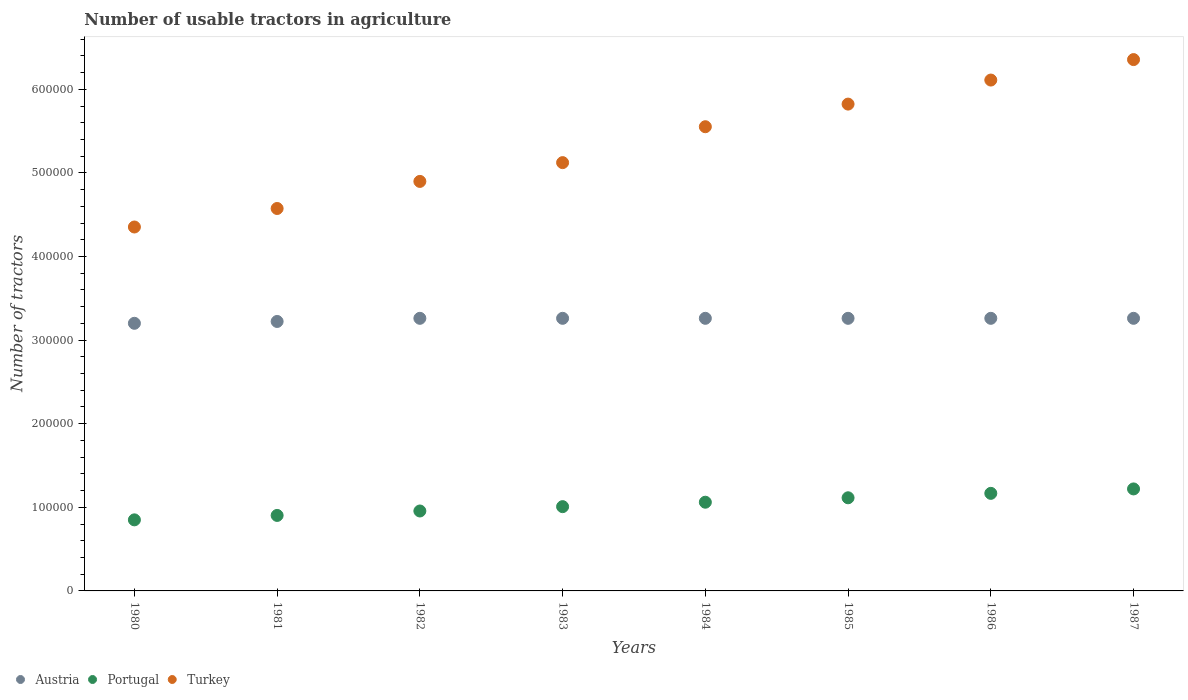What is the number of usable tractors in agriculture in Austria in 1981?
Your response must be concise. 3.22e+05. Across all years, what is the maximum number of usable tractors in agriculture in Portugal?
Provide a short and direct response. 1.22e+05. Across all years, what is the minimum number of usable tractors in agriculture in Portugal?
Provide a short and direct response. 8.50e+04. In which year was the number of usable tractors in agriculture in Austria maximum?
Offer a terse response. 1982. What is the total number of usable tractors in agriculture in Portugal in the graph?
Your answer should be compact. 8.28e+05. What is the difference between the number of usable tractors in agriculture in Turkey in 1982 and that in 1987?
Your answer should be very brief. -1.46e+05. What is the difference between the number of usable tractors in agriculture in Austria in 1984 and the number of usable tractors in agriculture in Portugal in 1987?
Keep it short and to the point. 2.04e+05. What is the average number of usable tractors in agriculture in Austria per year?
Make the answer very short. 3.25e+05. In the year 1987, what is the difference between the number of usable tractors in agriculture in Turkey and number of usable tractors in agriculture in Austria?
Offer a terse response. 3.09e+05. In how many years, is the number of usable tractors in agriculture in Portugal greater than 40000?
Provide a succinct answer. 8. What is the ratio of the number of usable tractors in agriculture in Portugal in 1980 to that in 1982?
Provide a succinct answer. 0.89. Is the number of usable tractors in agriculture in Austria in 1985 less than that in 1987?
Your answer should be very brief. No. What is the difference between the highest and the second highest number of usable tractors in agriculture in Portugal?
Give a very brief answer. 5300. What is the difference between the highest and the lowest number of usable tractors in agriculture in Portugal?
Offer a very short reply. 3.70e+04. In how many years, is the number of usable tractors in agriculture in Turkey greater than the average number of usable tractors in agriculture in Turkey taken over all years?
Offer a terse response. 4. Is the number of usable tractors in agriculture in Austria strictly less than the number of usable tractors in agriculture in Turkey over the years?
Offer a terse response. Yes. How many years are there in the graph?
Keep it short and to the point. 8. Are the values on the major ticks of Y-axis written in scientific E-notation?
Provide a succinct answer. No. Where does the legend appear in the graph?
Provide a short and direct response. Bottom left. How many legend labels are there?
Your response must be concise. 3. What is the title of the graph?
Provide a succinct answer. Number of usable tractors in agriculture. What is the label or title of the Y-axis?
Ensure brevity in your answer.  Number of tractors. What is the Number of tractors in Austria in 1980?
Offer a terse response. 3.20e+05. What is the Number of tractors of Portugal in 1980?
Provide a succinct answer. 8.50e+04. What is the Number of tractors of Turkey in 1980?
Offer a terse response. 4.35e+05. What is the Number of tractors of Austria in 1981?
Provide a succinct answer. 3.22e+05. What is the Number of tractors of Portugal in 1981?
Your answer should be compact. 9.03e+04. What is the Number of tractors of Turkey in 1981?
Offer a terse response. 4.57e+05. What is the Number of tractors in Austria in 1982?
Offer a terse response. 3.26e+05. What is the Number of tractors in Portugal in 1982?
Provide a succinct answer. 9.56e+04. What is the Number of tractors in Turkey in 1982?
Your answer should be compact. 4.90e+05. What is the Number of tractors of Austria in 1983?
Ensure brevity in your answer.  3.26e+05. What is the Number of tractors in Portugal in 1983?
Offer a very short reply. 1.01e+05. What is the Number of tractors of Turkey in 1983?
Provide a short and direct response. 5.12e+05. What is the Number of tractors of Austria in 1984?
Provide a succinct answer. 3.26e+05. What is the Number of tractors of Portugal in 1984?
Offer a very short reply. 1.06e+05. What is the Number of tractors in Turkey in 1984?
Offer a very short reply. 5.55e+05. What is the Number of tractors of Austria in 1985?
Ensure brevity in your answer.  3.26e+05. What is the Number of tractors in Portugal in 1985?
Keep it short and to the point. 1.11e+05. What is the Number of tractors in Turkey in 1985?
Make the answer very short. 5.82e+05. What is the Number of tractors in Austria in 1986?
Provide a succinct answer. 3.26e+05. What is the Number of tractors of Portugal in 1986?
Keep it short and to the point. 1.17e+05. What is the Number of tractors of Turkey in 1986?
Offer a very short reply. 6.11e+05. What is the Number of tractors of Austria in 1987?
Your answer should be very brief. 3.26e+05. What is the Number of tractors in Portugal in 1987?
Offer a terse response. 1.22e+05. What is the Number of tractors in Turkey in 1987?
Make the answer very short. 6.36e+05. Across all years, what is the maximum Number of tractors of Austria?
Your response must be concise. 3.26e+05. Across all years, what is the maximum Number of tractors in Portugal?
Your answer should be very brief. 1.22e+05. Across all years, what is the maximum Number of tractors of Turkey?
Offer a very short reply. 6.36e+05. Across all years, what is the minimum Number of tractors in Austria?
Your answer should be compact. 3.20e+05. Across all years, what is the minimum Number of tractors of Portugal?
Offer a very short reply. 8.50e+04. Across all years, what is the minimum Number of tractors in Turkey?
Ensure brevity in your answer.  4.35e+05. What is the total Number of tractors in Austria in the graph?
Offer a very short reply. 2.60e+06. What is the total Number of tractors in Portugal in the graph?
Offer a terse response. 8.28e+05. What is the total Number of tractors in Turkey in the graph?
Your response must be concise. 4.28e+06. What is the difference between the Number of tractors of Austria in 1980 and that in 1981?
Ensure brevity in your answer.  -2200. What is the difference between the Number of tractors of Portugal in 1980 and that in 1981?
Your response must be concise. -5300. What is the difference between the Number of tractors in Turkey in 1980 and that in 1981?
Your response must be concise. -2.21e+04. What is the difference between the Number of tractors of Austria in 1980 and that in 1982?
Keep it short and to the point. -5960. What is the difference between the Number of tractors of Portugal in 1980 and that in 1982?
Provide a succinct answer. -1.06e+04. What is the difference between the Number of tractors of Turkey in 1980 and that in 1982?
Make the answer very short. -5.45e+04. What is the difference between the Number of tractors of Austria in 1980 and that in 1983?
Keep it short and to the point. -5960. What is the difference between the Number of tractors in Portugal in 1980 and that in 1983?
Your answer should be compact. -1.58e+04. What is the difference between the Number of tractors of Turkey in 1980 and that in 1983?
Ensure brevity in your answer.  -7.70e+04. What is the difference between the Number of tractors of Austria in 1980 and that in 1984?
Your answer should be very brief. -5960. What is the difference between the Number of tractors of Portugal in 1980 and that in 1984?
Your answer should be very brief. -2.11e+04. What is the difference between the Number of tractors in Turkey in 1980 and that in 1984?
Your answer should be very brief. -1.20e+05. What is the difference between the Number of tractors of Austria in 1980 and that in 1985?
Offer a terse response. -5960. What is the difference between the Number of tractors of Portugal in 1980 and that in 1985?
Ensure brevity in your answer.  -2.64e+04. What is the difference between the Number of tractors of Turkey in 1980 and that in 1985?
Ensure brevity in your answer.  -1.47e+05. What is the difference between the Number of tractors in Austria in 1980 and that in 1986?
Offer a very short reply. -5960. What is the difference between the Number of tractors of Portugal in 1980 and that in 1986?
Offer a very short reply. -3.17e+04. What is the difference between the Number of tractors in Turkey in 1980 and that in 1986?
Make the answer very short. -1.76e+05. What is the difference between the Number of tractors of Austria in 1980 and that in 1987?
Make the answer very short. -5960. What is the difference between the Number of tractors of Portugal in 1980 and that in 1987?
Provide a succinct answer. -3.70e+04. What is the difference between the Number of tractors in Turkey in 1980 and that in 1987?
Your answer should be very brief. -2.00e+05. What is the difference between the Number of tractors of Austria in 1981 and that in 1982?
Your response must be concise. -3760. What is the difference between the Number of tractors in Portugal in 1981 and that in 1982?
Your answer should be compact. -5300. What is the difference between the Number of tractors in Turkey in 1981 and that in 1982?
Keep it short and to the point. -3.24e+04. What is the difference between the Number of tractors of Austria in 1981 and that in 1983?
Your answer should be compact. -3760. What is the difference between the Number of tractors in Portugal in 1981 and that in 1983?
Provide a succinct answer. -1.05e+04. What is the difference between the Number of tractors of Turkey in 1981 and that in 1983?
Your answer should be very brief. -5.49e+04. What is the difference between the Number of tractors in Austria in 1981 and that in 1984?
Provide a succinct answer. -3760. What is the difference between the Number of tractors of Portugal in 1981 and that in 1984?
Keep it short and to the point. -1.58e+04. What is the difference between the Number of tractors of Turkey in 1981 and that in 1984?
Ensure brevity in your answer.  -9.78e+04. What is the difference between the Number of tractors of Austria in 1981 and that in 1985?
Your answer should be very brief. -3760. What is the difference between the Number of tractors of Portugal in 1981 and that in 1985?
Provide a short and direct response. -2.11e+04. What is the difference between the Number of tractors of Turkey in 1981 and that in 1985?
Offer a terse response. -1.25e+05. What is the difference between the Number of tractors in Austria in 1981 and that in 1986?
Ensure brevity in your answer.  -3760. What is the difference between the Number of tractors of Portugal in 1981 and that in 1986?
Provide a short and direct response. -2.64e+04. What is the difference between the Number of tractors of Turkey in 1981 and that in 1986?
Offer a very short reply. -1.54e+05. What is the difference between the Number of tractors in Austria in 1981 and that in 1987?
Offer a very short reply. -3760. What is the difference between the Number of tractors of Portugal in 1981 and that in 1987?
Your response must be concise. -3.17e+04. What is the difference between the Number of tractors of Turkey in 1981 and that in 1987?
Offer a very short reply. -1.78e+05. What is the difference between the Number of tractors in Portugal in 1982 and that in 1983?
Your answer should be compact. -5200. What is the difference between the Number of tractors of Turkey in 1982 and that in 1983?
Give a very brief answer. -2.25e+04. What is the difference between the Number of tractors in Portugal in 1982 and that in 1984?
Give a very brief answer. -1.05e+04. What is the difference between the Number of tractors in Turkey in 1982 and that in 1984?
Make the answer very short. -6.54e+04. What is the difference between the Number of tractors in Portugal in 1982 and that in 1985?
Your response must be concise. -1.58e+04. What is the difference between the Number of tractors in Turkey in 1982 and that in 1985?
Your response must be concise. -9.25e+04. What is the difference between the Number of tractors of Portugal in 1982 and that in 1986?
Provide a succinct answer. -2.11e+04. What is the difference between the Number of tractors of Turkey in 1982 and that in 1986?
Keep it short and to the point. -1.21e+05. What is the difference between the Number of tractors of Portugal in 1982 and that in 1987?
Keep it short and to the point. -2.64e+04. What is the difference between the Number of tractors of Turkey in 1982 and that in 1987?
Provide a succinct answer. -1.46e+05. What is the difference between the Number of tractors of Portugal in 1983 and that in 1984?
Give a very brief answer. -5300. What is the difference between the Number of tractors in Turkey in 1983 and that in 1984?
Keep it short and to the point. -4.29e+04. What is the difference between the Number of tractors of Austria in 1983 and that in 1985?
Provide a succinct answer. 0. What is the difference between the Number of tractors in Portugal in 1983 and that in 1985?
Make the answer very short. -1.06e+04. What is the difference between the Number of tractors of Turkey in 1983 and that in 1985?
Your answer should be compact. -7.00e+04. What is the difference between the Number of tractors in Austria in 1983 and that in 1986?
Give a very brief answer. 0. What is the difference between the Number of tractors in Portugal in 1983 and that in 1986?
Your response must be concise. -1.59e+04. What is the difference between the Number of tractors of Turkey in 1983 and that in 1986?
Ensure brevity in your answer.  -9.88e+04. What is the difference between the Number of tractors of Portugal in 1983 and that in 1987?
Provide a short and direct response. -2.12e+04. What is the difference between the Number of tractors of Turkey in 1983 and that in 1987?
Ensure brevity in your answer.  -1.23e+05. What is the difference between the Number of tractors in Portugal in 1984 and that in 1985?
Give a very brief answer. -5300. What is the difference between the Number of tractors in Turkey in 1984 and that in 1985?
Offer a very short reply. -2.71e+04. What is the difference between the Number of tractors in Portugal in 1984 and that in 1986?
Ensure brevity in your answer.  -1.06e+04. What is the difference between the Number of tractors in Turkey in 1984 and that in 1986?
Provide a short and direct response. -5.58e+04. What is the difference between the Number of tractors in Austria in 1984 and that in 1987?
Your answer should be compact. 0. What is the difference between the Number of tractors of Portugal in 1984 and that in 1987?
Your answer should be very brief. -1.59e+04. What is the difference between the Number of tractors in Turkey in 1984 and that in 1987?
Ensure brevity in your answer.  -8.03e+04. What is the difference between the Number of tractors of Portugal in 1985 and that in 1986?
Provide a short and direct response. -5300. What is the difference between the Number of tractors of Turkey in 1985 and that in 1986?
Your response must be concise. -2.88e+04. What is the difference between the Number of tractors in Austria in 1985 and that in 1987?
Your response must be concise. 0. What is the difference between the Number of tractors of Portugal in 1985 and that in 1987?
Keep it short and to the point. -1.06e+04. What is the difference between the Number of tractors of Turkey in 1985 and that in 1987?
Give a very brief answer. -5.32e+04. What is the difference between the Number of tractors in Portugal in 1986 and that in 1987?
Your answer should be very brief. -5300. What is the difference between the Number of tractors in Turkey in 1986 and that in 1987?
Make the answer very short. -2.45e+04. What is the difference between the Number of tractors of Austria in 1980 and the Number of tractors of Portugal in 1981?
Offer a very short reply. 2.30e+05. What is the difference between the Number of tractors in Austria in 1980 and the Number of tractors in Turkey in 1981?
Offer a terse response. -1.37e+05. What is the difference between the Number of tractors in Portugal in 1980 and the Number of tractors in Turkey in 1981?
Give a very brief answer. -3.72e+05. What is the difference between the Number of tractors in Austria in 1980 and the Number of tractors in Portugal in 1982?
Ensure brevity in your answer.  2.24e+05. What is the difference between the Number of tractors in Austria in 1980 and the Number of tractors in Turkey in 1982?
Offer a very short reply. -1.70e+05. What is the difference between the Number of tractors in Portugal in 1980 and the Number of tractors in Turkey in 1982?
Provide a short and direct response. -4.05e+05. What is the difference between the Number of tractors of Austria in 1980 and the Number of tractors of Portugal in 1983?
Provide a short and direct response. 2.19e+05. What is the difference between the Number of tractors of Austria in 1980 and the Number of tractors of Turkey in 1983?
Make the answer very short. -1.92e+05. What is the difference between the Number of tractors of Portugal in 1980 and the Number of tractors of Turkey in 1983?
Ensure brevity in your answer.  -4.27e+05. What is the difference between the Number of tractors of Austria in 1980 and the Number of tractors of Portugal in 1984?
Provide a succinct answer. 2.14e+05. What is the difference between the Number of tractors in Austria in 1980 and the Number of tractors in Turkey in 1984?
Your answer should be very brief. -2.35e+05. What is the difference between the Number of tractors of Portugal in 1980 and the Number of tractors of Turkey in 1984?
Your answer should be compact. -4.70e+05. What is the difference between the Number of tractors of Austria in 1980 and the Number of tractors of Portugal in 1985?
Offer a terse response. 2.09e+05. What is the difference between the Number of tractors in Austria in 1980 and the Number of tractors in Turkey in 1985?
Your answer should be compact. -2.62e+05. What is the difference between the Number of tractors in Portugal in 1980 and the Number of tractors in Turkey in 1985?
Provide a short and direct response. -4.97e+05. What is the difference between the Number of tractors of Austria in 1980 and the Number of tractors of Portugal in 1986?
Keep it short and to the point. 2.03e+05. What is the difference between the Number of tractors of Austria in 1980 and the Number of tractors of Turkey in 1986?
Give a very brief answer. -2.91e+05. What is the difference between the Number of tractors in Portugal in 1980 and the Number of tractors in Turkey in 1986?
Ensure brevity in your answer.  -5.26e+05. What is the difference between the Number of tractors in Austria in 1980 and the Number of tractors in Portugal in 1987?
Offer a very short reply. 1.98e+05. What is the difference between the Number of tractors in Austria in 1980 and the Number of tractors in Turkey in 1987?
Your response must be concise. -3.15e+05. What is the difference between the Number of tractors in Portugal in 1980 and the Number of tractors in Turkey in 1987?
Your response must be concise. -5.51e+05. What is the difference between the Number of tractors of Austria in 1981 and the Number of tractors of Portugal in 1982?
Your response must be concise. 2.27e+05. What is the difference between the Number of tractors of Austria in 1981 and the Number of tractors of Turkey in 1982?
Your answer should be compact. -1.68e+05. What is the difference between the Number of tractors in Portugal in 1981 and the Number of tractors in Turkey in 1982?
Make the answer very short. -4.00e+05. What is the difference between the Number of tractors of Austria in 1981 and the Number of tractors of Portugal in 1983?
Ensure brevity in your answer.  2.22e+05. What is the difference between the Number of tractors in Austria in 1981 and the Number of tractors in Turkey in 1983?
Offer a very short reply. -1.90e+05. What is the difference between the Number of tractors of Portugal in 1981 and the Number of tractors of Turkey in 1983?
Make the answer very short. -4.22e+05. What is the difference between the Number of tractors in Austria in 1981 and the Number of tractors in Portugal in 1984?
Ensure brevity in your answer.  2.16e+05. What is the difference between the Number of tractors of Austria in 1981 and the Number of tractors of Turkey in 1984?
Offer a very short reply. -2.33e+05. What is the difference between the Number of tractors of Portugal in 1981 and the Number of tractors of Turkey in 1984?
Ensure brevity in your answer.  -4.65e+05. What is the difference between the Number of tractors of Austria in 1981 and the Number of tractors of Portugal in 1985?
Provide a succinct answer. 2.11e+05. What is the difference between the Number of tractors in Austria in 1981 and the Number of tractors in Turkey in 1985?
Keep it short and to the point. -2.60e+05. What is the difference between the Number of tractors in Portugal in 1981 and the Number of tractors in Turkey in 1985?
Ensure brevity in your answer.  -4.92e+05. What is the difference between the Number of tractors in Austria in 1981 and the Number of tractors in Portugal in 1986?
Provide a short and direct response. 2.06e+05. What is the difference between the Number of tractors of Austria in 1981 and the Number of tractors of Turkey in 1986?
Your answer should be compact. -2.89e+05. What is the difference between the Number of tractors in Portugal in 1981 and the Number of tractors in Turkey in 1986?
Offer a terse response. -5.21e+05. What is the difference between the Number of tractors in Austria in 1981 and the Number of tractors in Portugal in 1987?
Make the answer very short. 2.00e+05. What is the difference between the Number of tractors of Austria in 1981 and the Number of tractors of Turkey in 1987?
Make the answer very short. -3.13e+05. What is the difference between the Number of tractors in Portugal in 1981 and the Number of tractors in Turkey in 1987?
Offer a terse response. -5.45e+05. What is the difference between the Number of tractors in Austria in 1982 and the Number of tractors in Portugal in 1983?
Ensure brevity in your answer.  2.25e+05. What is the difference between the Number of tractors of Austria in 1982 and the Number of tractors of Turkey in 1983?
Provide a succinct answer. -1.86e+05. What is the difference between the Number of tractors in Portugal in 1982 and the Number of tractors in Turkey in 1983?
Provide a short and direct response. -4.17e+05. What is the difference between the Number of tractors of Austria in 1982 and the Number of tractors of Portugal in 1984?
Give a very brief answer. 2.20e+05. What is the difference between the Number of tractors in Austria in 1982 and the Number of tractors in Turkey in 1984?
Your response must be concise. -2.29e+05. What is the difference between the Number of tractors of Portugal in 1982 and the Number of tractors of Turkey in 1984?
Give a very brief answer. -4.60e+05. What is the difference between the Number of tractors in Austria in 1982 and the Number of tractors in Portugal in 1985?
Provide a succinct answer. 2.15e+05. What is the difference between the Number of tractors of Austria in 1982 and the Number of tractors of Turkey in 1985?
Provide a short and direct response. -2.56e+05. What is the difference between the Number of tractors of Portugal in 1982 and the Number of tractors of Turkey in 1985?
Keep it short and to the point. -4.87e+05. What is the difference between the Number of tractors of Austria in 1982 and the Number of tractors of Portugal in 1986?
Make the answer very short. 2.09e+05. What is the difference between the Number of tractors of Austria in 1982 and the Number of tractors of Turkey in 1986?
Keep it short and to the point. -2.85e+05. What is the difference between the Number of tractors of Portugal in 1982 and the Number of tractors of Turkey in 1986?
Your response must be concise. -5.15e+05. What is the difference between the Number of tractors in Austria in 1982 and the Number of tractors in Portugal in 1987?
Give a very brief answer. 2.04e+05. What is the difference between the Number of tractors in Austria in 1982 and the Number of tractors in Turkey in 1987?
Your answer should be compact. -3.09e+05. What is the difference between the Number of tractors of Portugal in 1982 and the Number of tractors of Turkey in 1987?
Offer a terse response. -5.40e+05. What is the difference between the Number of tractors in Austria in 1983 and the Number of tractors in Portugal in 1984?
Your response must be concise. 2.20e+05. What is the difference between the Number of tractors in Austria in 1983 and the Number of tractors in Turkey in 1984?
Offer a very short reply. -2.29e+05. What is the difference between the Number of tractors in Portugal in 1983 and the Number of tractors in Turkey in 1984?
Give a very brief answer. -4.54e+05. What is the difference between the Number of tractors in Austria in 1983 and the Number of tractors in Portugal in 1985?
Offer a very short reply. 2.15e+05. What is the difference between the Number of tractors in Austria in 1983 and the Number of tractors in Turkey in 1985?
Provide a succinct answer. -2.56e+05. What is the difference between the Number of tractors in Portugal in 1983 and the Number of tractors in Turkey in 1985?
Your answer should be compact. -4.81e+05. What is the difference between the Number of tractors of Austria in 1983 and the Number of tractors of Portugal in 1986?
Offer a terse response. 2.09e+05. What is the difference between the Number of tractors of Austria in 1983 and the Number of tractors of Turkey in 1986?
Your answer should be very brief. -2.85e+05. What is the difference between the Number of tractors in Portugal in 1983 and the Number of tractors in Turkey in 1986?
Provide a succinct answer. -5.10e+05. What is the difference between the Number of tractors of Austria in 1983 and the Number of tractors of Portugal in 1987?
Ensure brevity in your answer.  2.04e+05. What is the difference between the Number of tractors in Austria in 1983 and the Number of tractors in Turkey in 1987?
Offer a terse response. -3.09e+05. What is the difference between the Number of tractors in Portugal in 1983 and the Number of tractors in Turkey in 1987?
Offer a very short reply. -5.35e+05. What is the difference between the Number of tractors of Austria in 1984 and the Number of tractors of Portugal in 1985?
Provide a succinct answer. 2.15e+05. What is the difference between the Number of tractors of Austria in 1984 and the Number of tractors of Turkey in 1985?
Keep it short and to the point. -2.56e+05. What is the difference between the Number of tractors in Portugal in 1984 and the Number of tractors in Turkey in 1985?
Your answer should be compact. -4.76e+05. What is the difference between the Number of tractors in Austria in 1984 and the Number of tractors in Portugal in 1986?
Provide a succinct answer. 2.09e+05. What is the difference between the Number of tractors of Austria in 1984 and the Number of tractors of Turkey in 1986?
Your response must be concise. -2.85e+05. What is the difference between the Number of tractors in Portugal in 1984 and the Number of tractors in Turkey in 1986?
Make the answer very short. -5.05e+05. What is the difference between the Number of tractors in Austria in 1984 and the Number of tractors in Portugal in 1987?
Your answer should be compact. 2.04e+05. What is the difference between the Number of tractors in Austria in 1984 and the Number of tractors in Turkey in 1987?
Offer a terse response. -3.09e+05. What is the difference between the Number of tractors of Portugal in 1984 and the Number of tractors of Turkey in 1987?
Provide a short and direct response. -5.29e+05. What is the difference between the Number of tractors in Austria in 1985 and the Number of tractors in Portugal in 1986?
Offer a terse response. 2.09e+05. What is the difference between the Number of tractors in Austria in 1985 and the Number of tractors in Turkey in 1986?
Your answer should be compact. -2.85e+05. What is the difference between the Number of tractors in Portugal in 1985 and the Number of tractors in Turkey in 1986?
Ensure brevity in your answer.  -5.00e+05. What is the difference between the Number of tractors of Austria in 1985 and the Number of tractors of Portugal in 1987?
Your answer should be very brief. 2.04e+05. What is the difference between the Number of tractors in Austria in 1985 and the Number of tractors in Turkey in 1987?
Your answer should be very brief. -3.09e+05. What is the difference between the Number of tractors of Portugal in 1985 and the Number of tractors of Turkey in 1987?
Offer a very short reply. -5.24e+05. What is the difference between the Number of tractors of Austria in 1986 and the Number of tractors of Portugal in 1987?
Keep it short and to the point. 2.04e+05. What is the difference between the Number of tractors in Austria in 1986 and the Number of tractors in Turkey in 1987?
Offer a very short reply. -3.09e+05. What is the difference between the Number of tractors in Portugal in 1986 and the Number of tractors in Turkey in 1987?
Keep it short and to the point. -5.19e+05. What is the average Number of tractors in Austria per year?
Ensure brevity in your answer.  3.25e+05. What is the average Number of tractors in Portugal per year?
Provide a short and direct response. 1.03e+05. What is the average Number of tractors of Turkey per year?
Offer a very short reply. 5.35e+05. In the year 1980, what is the difference between the Number of tractors of Austria and Number of tractors of Portugal?
Your answer should be compact. 2.35e+05. In the year 1980, what is the difference between the Number of tractors in Austria and Number of tractors in Turkey?
Offer a terse response. -1.15e+05. In the year 1980, what is the difference between the Number of tractors in Portugal and Number of tractors in Turkey?
Your response must be concise. -3.50e+05. In the year 1981, what is the difference between the Number of tractors of Austria and Number of tractors of Portugal?
Ensure brevity in your answer.  2.32e+05. In the year 1981, what is the difference between the Number of tractors of Austria and Number of tractors of Turkey?
Give a very brief answer. -1.35e+05. In the year 1981, what is the difference between the Number of tractors in Portugal and Number of tractors in Turkey?
Provide a succinct answer. -3.67e+05. In the year 1982, what is the difference between the Number of tractors of Austria and Number of tractors of Portugal?
Keep it short and to the point. 2.30e+05. In the year 1982, what is the difference between the Number of tractors of Austria and Number of tractors of Turkey?
Offer a very short reply. -1.64e+05. In the year 1982, what is the difference between the Number of tractors of Portugal and Number of tractors of Turkey?
Your response must be concise. -3.94e+05. In the year 1983, what is the difference between the Number of tractors of Austria and Number of tractors of Portugal?
Your answer should be very brief. 2.25e+05. In the year 1983, what is the difference between the Number of tractors in Austria and Number of tractors in Turkey?
Provide a short and direct response. -1.86e+05. In the year 1983, what is the difference between the Number of tractors in Portugal and Number of tractors in Turkey?
Provide a short and direct response. -4.11e+05. In the year 1984, what is the difference between the Number of tractors of Austria and Number of tractors of Portugal?
Offer a very short reply. 2.20e+05. In the year 1984, what is the difference between the Number of tractors in Austria and Number of tractors in Turkey?
Your response must be concise. -2.29e+05. In the year 1984, what is the difference between the Number of tractors of Portugal and Number of tractors of Turkey?
Your response must be concise. -4.49e+05. In the year 1985, what is the difference between the Number of tractors of Austria and Number of tractors of Portugal?
Your answer should be compact. 2.15e+05. In the year 1985, what is the difference between the Number of tractors in Austria and Number of tractors in Turkey?
Ensure brevity in your answer.  -2.56e+05. In the year 1985, what is the difference between the Number of tractors of Portugal and Number of tractors of Turkey?
Ensure brevity in your answer.  -4.71e+05. In the year 1986, what is the difference between the Number of tractors in Austria and Number of tractors in Portugal?
Ensure brevity in your answer.  2.09e+05. In the year 1986, what is the difference between the Number of tractors in Austria and Number of tractors in Turkey?
Provide a succinct answer. -2.85e+05. In the year 1986, what is the difference between the Number of tractors in Portugal and Number of tractors in Turkey?
Provide a short and direct response. -4.94e+05. In the year 1987, what is the difference between the Number of tractors in Austria and Number of tractors in Portugal?
Your response must be concise. 2.04e+05. In the year 1987, what is the difference between the Number of tractors in Austria and Number of tractors in Turkey?
Offer a terse response. -3.09e+05. In the year 1987, what is the difference between the Number of tractors of Portugal and Number of tractors of Turkey?
Give a very brief answer. -5.14e+05. What is the ratio of the Number of tractors of Portugal in 1980 to that in 1981?
Your response must be concise. 0.94. What is the ratio of the Number of tractors in Turkey in 1980 to that in 1981?
Your answer should be very brief. 0.95. What is the ratio of the Number of tractors of Austria in 1980 to that in 1982?
Your answer should be very brief. 0.98. What is the ratio of the Number of tractors in Portugal in 1980 to that in 1982?
Offer a very short reply. 0.89. What is the ratio of the Number of tractors in Turkey in 1980 to that in 1982?
Offer a very short reply. 0.89. What is the ratio of the Number of tractors of Austria in 1980 to that in 1983?
Provide a succinct answer. 0.98. What is the ratio of the Number of tractors in Portugal in 1980 to that in 1983?
Give a very brief answer. 0.84. What is the ratio of the Number of tractors in Turkey in 1980 to that in 1983?
Offer a very short reply. 0.85. What is the ratio of the Number of tractors of Austria in 1980 to that in 1984?
Your answer should be compact. 0.98. What is the ratio of the Number of tractors of Portugal in 1980 to that in 1984?
Provide a succinct answer. 0.8. What is the ratio of the Number of tractors in Turkey in 1980 to that in 1984?
Your answer should be compact. 0.78. What is the ratio of the Number of tractors of Austria in 1980 to that in 1985?
Make the answer very short. 0.98. What is the ratio of the Number of tractors of Portugal in 1980 to that in 1985?
Your response must be concise. 0.76. What is the ratio of the Number of tractors of Turkey in 1980 to that in 1985?
Keep it short and to the point. 0.75. What is the ratio of the Number of tractors of Austria in 1980 to that in 1986?
Your response must be concise. 0.98. What is the ratio of the Number of tractors of Portugal in 1980 to that in 1986?
Provide a short and direct response. 0.73. What is the ratio of the Number of tractors in Turkey in 1980 to that in 1986?
Your answer should be compact. 0.71. What is the ratio of the Number of tractors in Austria in 1980 to that in 1987?
Your response must be concise. 0.98. What is the ratio of the Number of tractors of Portugal in 1980 to that in 1987?
Your response must be concise. 0.7. What is the ratio of the Number of tractors of Turkey in 1980 to that in 1987?
Provide a succinct answer. 0.68. What is the ratio of the Number of tractors in Portugal in 1981 to that in 1982?
Give a very brief answer. 0.94. What is the ratio of the Number of tractors in Turkey in 1981 to that in 1982?
Give a very brief answer. 0.93. What is the ratio of the Number of tractors of Portugal in 1981 to that in 1983?
Provide a short and direct response. 0.9. What is the ratio of the Number of tractors in Turkey in 1981 to that in 1983?
Offer a terse response. 0.89. What is the ratio of the Number of tractors in Portugal in 1981 to that in 1984?
Make the answer very short. 0.85. What is the ratio of the Number of tractors in Turkey in 1981 to that in 1984?
Provide a succinct answer. 0.82. What is the ratio of the Number of tractors of Portugal in 1981 to that in 1985?
Provide a short and direct response. 0.81. What is the ratio of the Number of tractors of Turkey in 1981 to that in 1985?
Give a very brief answer. 0.79. What is the ratio of the Number of tractors of Austria in 1981 to that in 1986?
Your answer should be very brief. 0.99. What is the ratio of the Number of tractors in Portugal in 1981 to that in 1986?
Provide a succinct answer. 0.77. What is the ratio of the Number of tractors of Turkey in 1981 to that in 1986?
Keep it short and to the point. 0.75. What is the ratio of the Number of tractors in Austria in 1981 to that in 1987?
Ensure brevity in your answer.  0.99. What is the ratio of the Number of tractors of Portugal in 1981 to that in 1987?
Offer a very short reply. 0.74. What is the ratio of the Number of tractors of Turkey in 1981 to that in 1987?
Keep it short and to the point. 0.72. What is the ratio of the Number of tractors in Austria in 1982 to that in 1983?
Your answer should be very brief. 1. What is the ratio of the Number of tractors in Portugal in 1982 to that in 1983?
Offer a terse response. 0.95. What is the ratio of the Number of tractors of Turkey in 1982 to that in 1983?
Offer a terse response. 0.96. What is the ratio of the Number of tractors in Portugal in 1982 to that in 1984?
Your answer should be compact. 0.9. What is the ratio of the Number of tractors of Turkey in 1982 to that in 1984?
Offer a terse response. 0.88. What is the ratio of the Number of tractors in Austria in 1982 to that in 1985?
Your answer should be very brief. 1. What is the ratio of the Number of tractors of Portugal in 1982 to that in 1985?
Ensure brevity in your answer.  0.86. What is the ratio of the Number of tractors of Turkey in 1982 to that in 1985?
Provide a short and direct response. 0.84. What is the ratio of the Number of tractors of Portugal in 1982 to that in 1986?
Your answer should be very brief. 0.82. What is the ratio of the Number of tractors of Turkey in 1982 to that in 1986?
Provide a succinct answer. 0.8. What is the ratio of the Number of tractors of Portugal in 1982 to that in 1987?
Provide a succinct answer. 0.78. What is the ratio of the Number of tractors in Turkey in 1982 to that in 1987?
Your response must be concise. 0.77. What is the ratio of the Number of tractors of Portugal in 1983 to that in 1984?
Your answer should be compact. 0.95. What is the ratio of the Number of tractors of Turkey in 1983 to that in 1984?
Keep it short and to the point. 0.92. What is the ratio of the Number of tractors of Portugal in 1983 to that in 1985?
Offer a terse response. 0.9. What is the ratio of the Number of tractors in Turkey in 1983 to that in 1985?
Offer a terse response. 0.88. What is the ratio of the Number of tractors in Austria in 1983 to that in 1986?
Offer a very short reply. 1. What is the ratio of the Number of tractors in Portugal in 1983 to that in 1986?
Your answer should be very brief. 0.86. What is the ratio of the Number of tractors in Turkey in 1983 to that in 1986?
Offer a terse response. 0.84. What is the ratio of the Number of tractors in Austria in 1983 to that in 1987?
Provide a succinct answer. 1. What is the ratio of the Number of tractors of Portugal in 1983 to that in 1987?
Provide a succinct answer. 0.83. What is the ratio of the Number of tractors of Turkey in 1983 to that in 1987?
Give a very brief answer. 0.81. What is the ratio of the Number of tractors of Austria in 1984 to that in 1985?
Offer a terse response. 1. What is the ratio of the Number of tractors of Turkey in 1984 to that in 1985?
Offer a very short reply. 0.95. What is the ratio of the Number of tractors of Portugal in 1984 to that in 1986?
Offer a terse response. 0.91. What is the ratio of the Number of tractors in Turkey in 1984 to that in 1986?
Give a very brief answer. 0.91. What is the ratio of the Number of tractors of Portugal in 1984 to that in 1987?
Make the answer very short. 0.87. What is the ratio of the Number of tractors of Turkey in 1984 to that in 1987?
Keep it short and to the point. 0.87. What is the ratio of the Number of tractors of Portugal in 1985 to that in 1986?
Keep it short and to the point. 0.95. What is the ratio of the Number of tractors in Turkey in 1985 to that in 1986?
Provide a short and direct response. 0.95. What is the ratio of the Number of tractors of Portugal in 1985 to that in 1987?
Offer a terse response. 0.91. What is the ratio of the Number of tractors of Turkey in 1985 to that in 1987?
Your response must be concise. 0.92. What is the ratio of the Number of tractors in Austria in 1986 to that in 1987?
Give a very brief answer. 1. What is the ratio of the Number of tractors of Portugal in 1986 to that in 1987?
Your answer should be compact. 0.96. What is the ratio of the Number of tractors in Turkey in 1986 to that in 1987?
Offer a very short reply. 0.96. What is the difference between the highest and the second highest Number of tractors in Portugal?
Offer a terse response. 5300. What is the difference between the highest and the second highest Number of tractors in Turkey?
Give a very brief answer. 2.45e+04. What is the difference between the highest and the lowest Number of tractors of Austria?
Provide a succinct answer. 5960. What is the difference between the highest and the lowest Number of tractors in Portugal?
Your response must be concise. 3.70e+04. What is the difference between the highest and the lowest Number of tractors in Turkey?
Offer a very short reply. 2.00e+05. 